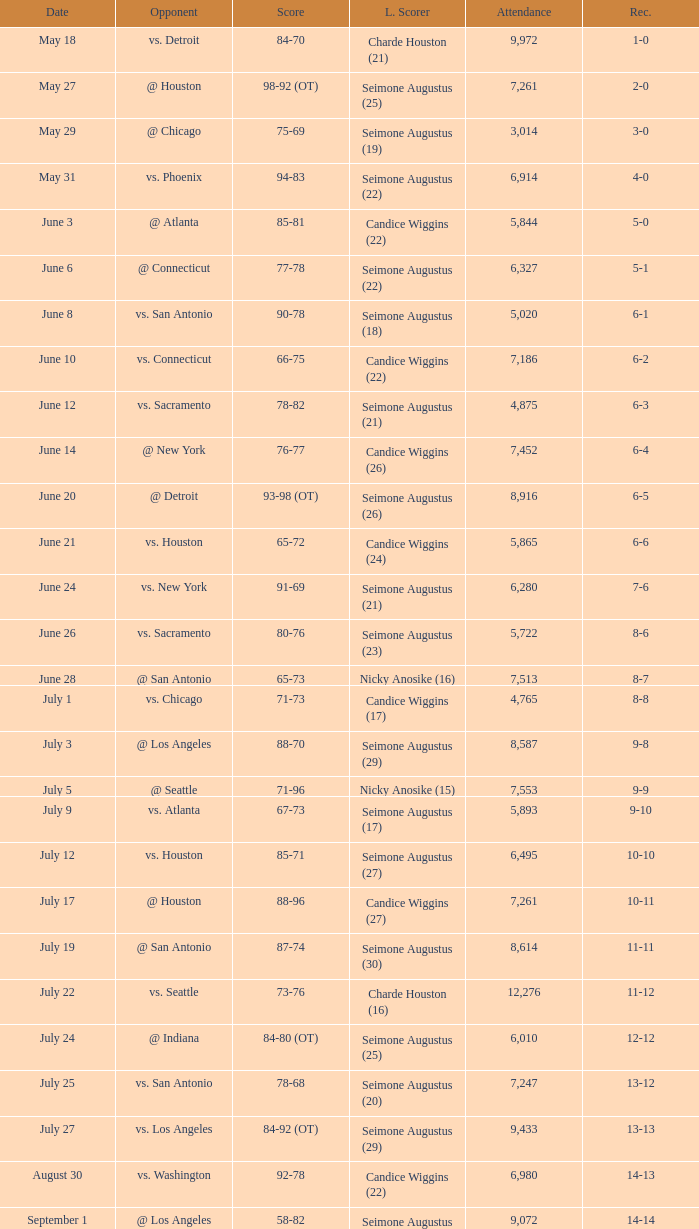Which Attendance has a Date of september 7? 7999.0. 